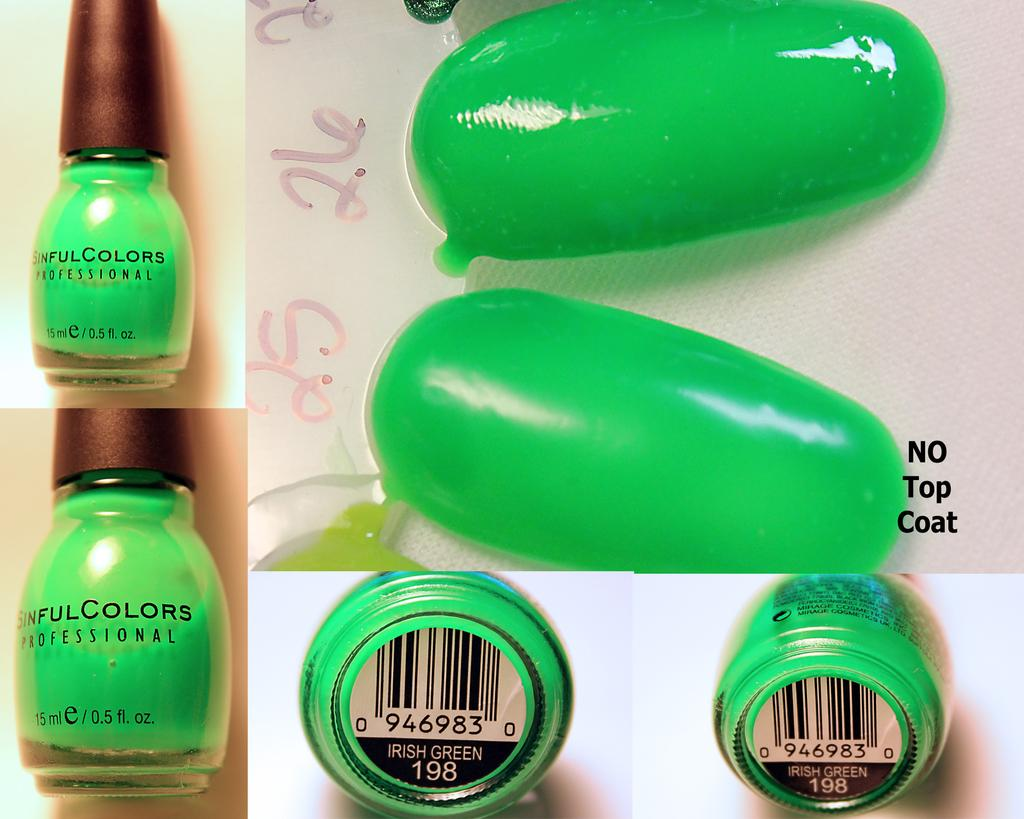<image>
Present a compact description of the photo's key features. Sinful Colors professional nail polish Irish Green 946983 